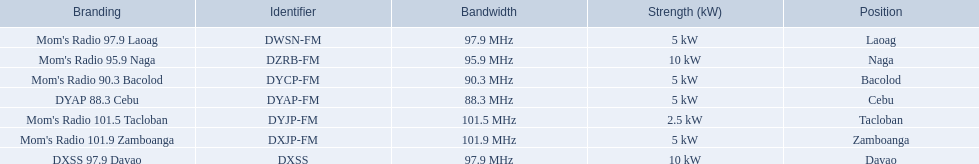Which stations use less than 10kw of power? Mom's Radio 97.9 Laoag, Mom's Radio 90.3 Bacolod, DYAP 88.3 Cebu, Mom's Radio 101.5 Tacloban, Mom's Radio 101.9 Zamboanga. Do any stations use less than 5kw of power? if so, which ones? Mom's Radio 101.5 Tacloban. 